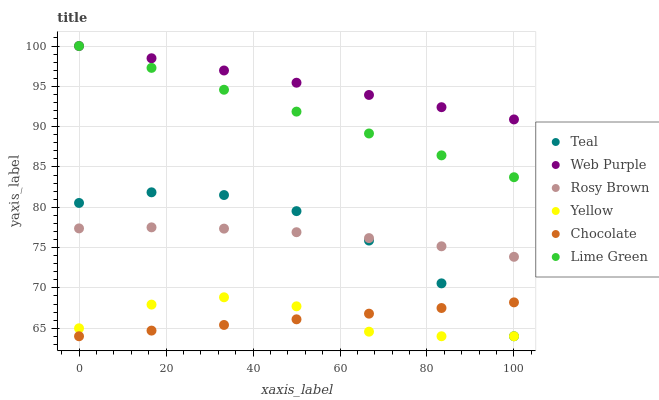Does Chocolate have the minimum area under the curve?
Answer yes or no. Yes. Does Web Purple have the maximum area under the curve?
Answer yes or no. Yes. Does Yellow have the minimum area under the curve?
Answer yes or no. No. Does Yellow have the maximum area under the curve?
Answer yes or no. No. Is Web Purple the smoothest?
Answer yes or no. Yes. Is Yellow the roughest?
Answer yes or no. Yes. Is Chocolate the smoothest?
Answer yes or no. No. Is Chocolate the roughest?
Answer yes or no. No. Does Yellow have the lowest value?
Answer yes or no. Yes. Does Web Purple have the lowest value?
Answer yes or no. No. Does Lime Green have the highest value?
Answer yes or no. Yes. Does Yellow have the highest value?
Answer yes or no. No. Is Chocolate less than Web Purple?
Answer yes or no. Yes. Is Lime Green greater than Teal?
Answer yes or no. Yes. Does Web Purple intersect Lime Green?
Answer yes or no. Yes. Is Web Purple less than Lime Green?
Answer yes or no. No. Is Web Purple greater than Lime Green?
Answer yes or no. No. Does Chocolate intersect Web Purple?
Answer yes or no. No. 